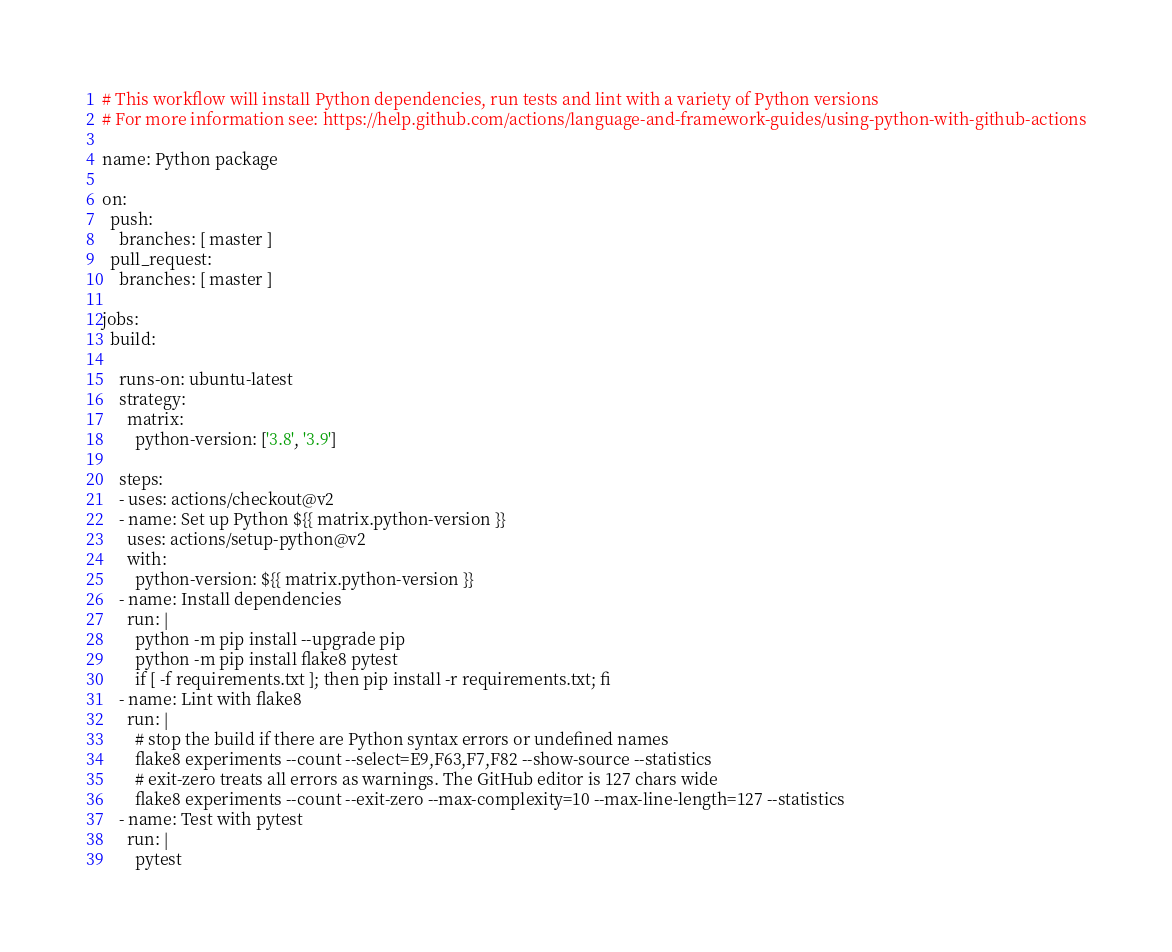Convert code to text. <code><loc_0><loc_0><loc_500><loc_500><_YAML_># This workflow will install Python dependencies, run tests and lint with a variety of Python versions
# For more information see: https://help.github.com/actions/language-and-framework-guides/using-python-with-github-actions

name: Python package

on:
  push:
    branches: [ master ]
  pull_request:
    branches: [ master ]

jobs:
  build:

    runs-on: ubuntu-latest
    strategy:
      matrix:
        python-version: ['3.8', '3.9']

    steps:
    - uses: actions/checkout@v2
    - name: Set up Python ${{ matrix.python-version }}
      uses: actions/setup-python@v2
      with:
        python-version: ${{ matrix.python-version }}
    - name: Install dependencies
      run: |
        python -m pip install --upgrade pip
        python -m pip install flake8 pytest
        if [ -f requirements.txt ]; then pip install -r requirements.txt; fi
    - name: Lint with flake8
      run: |
        # stop the build if there are Python syntax errors or undefined names
        flake8 experiments --count --select=E9,F63,F7,F82 --show-source --statistics
        # exit-zero treats all errors as warnings. The GitHub editor is 127 chars wide
        flake8 experiments --count --exit-zero --max-complexity=10 --max-line-length=127 --statistics
    - name: Test with pytest
      run: |
        pytest
</code> 